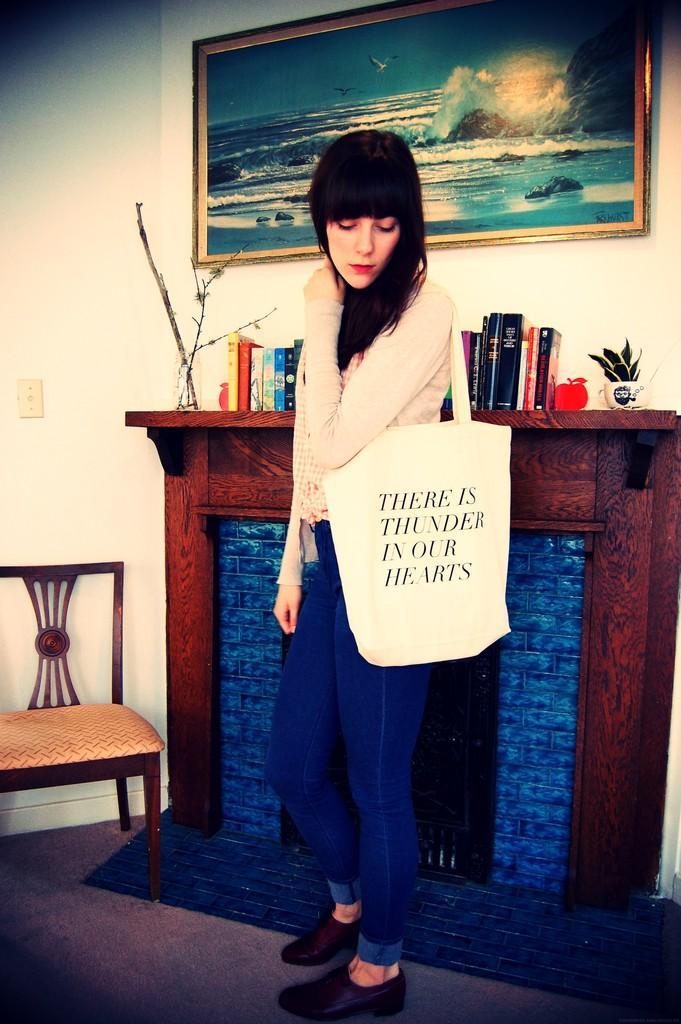Can you describe this image briefly? There is a woman standing on the floor and she wore a bag. Here we can see a chair, books, and plants. In the background we can see a frame and wall. 